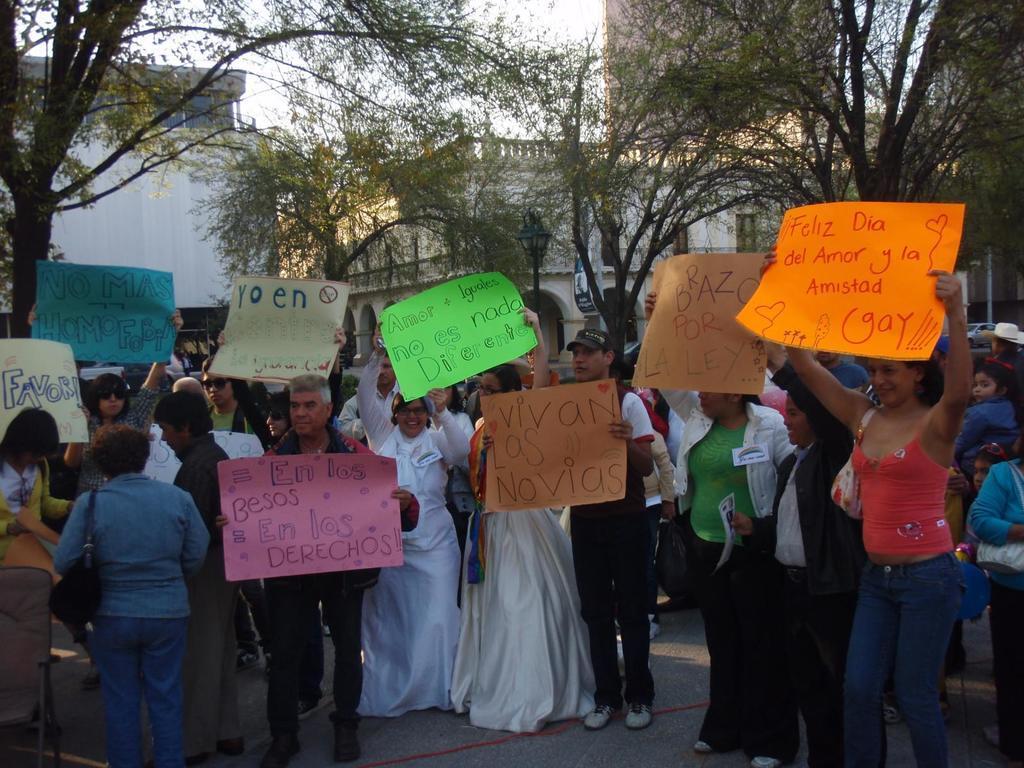Can you describe this image briefly? In the center of the image we can see people standing and holding boards in their hands. In the background there are trees, buildings and sky. 